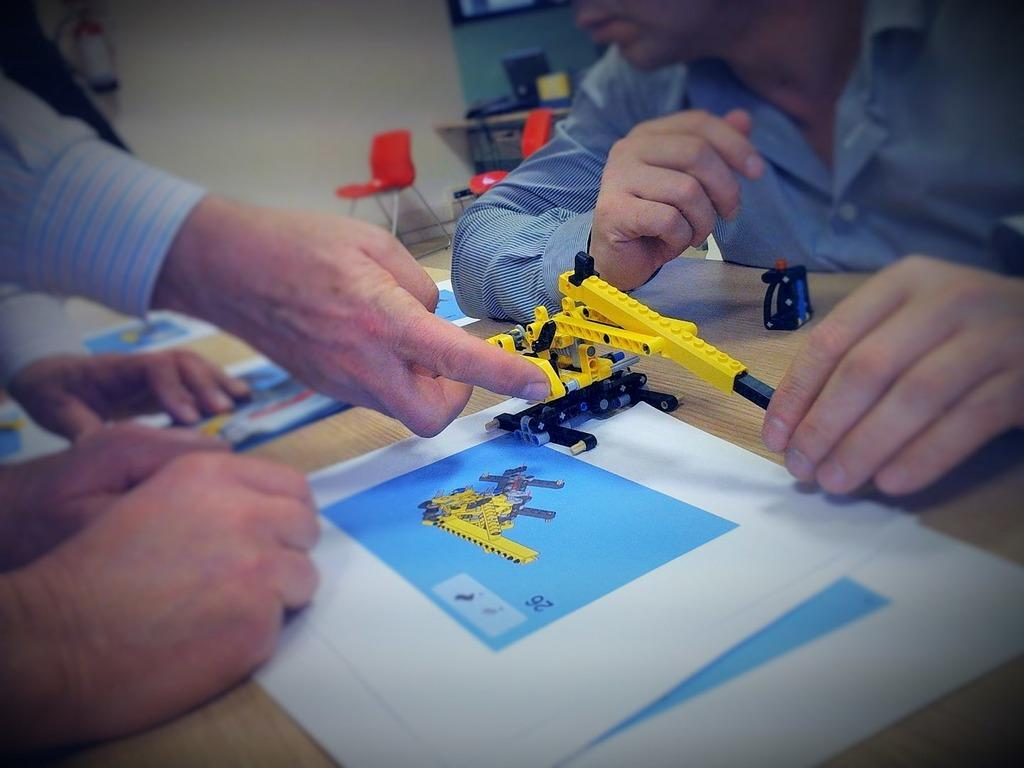What is happening around the table in the image? There are persons around the table in the image. What items can be seen on the table? Legos and papers are present on the table. What can be seen in the background of the image? There are chairs, another table, a computer, and a wall visible in the background. Is there a cactus present in the image? No, there is no cactus visible in the image. 